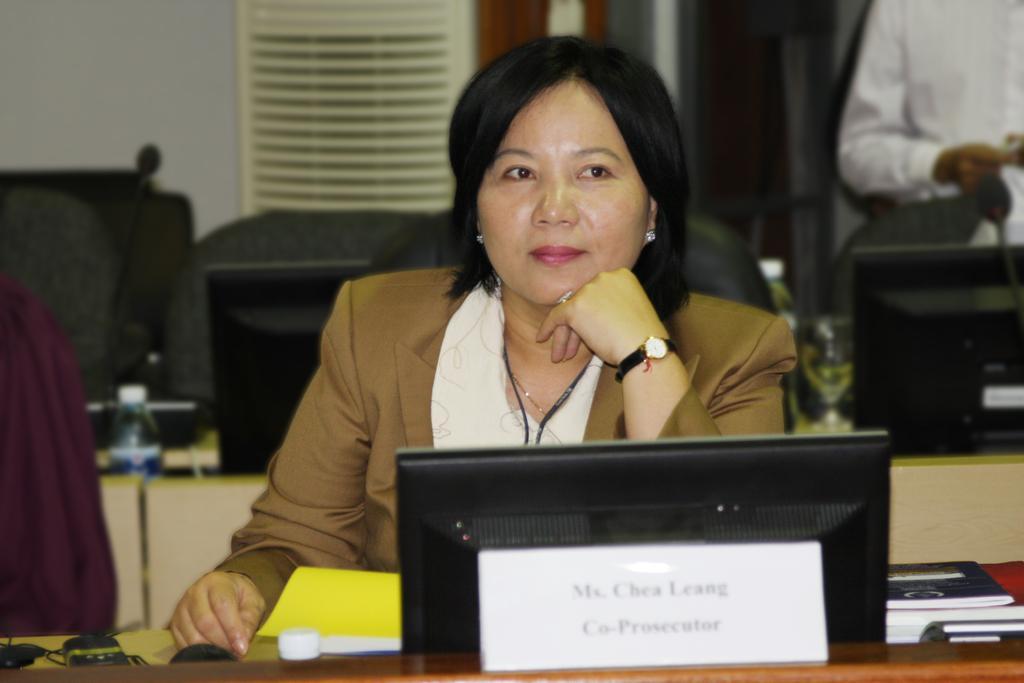Please provide a concise description of this image. In the middle of this image, there is a woman in a suit, sitting and panting a hand on the table, on which there are books, a screen, name plate and other objects arranged. In the background, there is another person sitting, there is a white wall, glasses and other objects. 